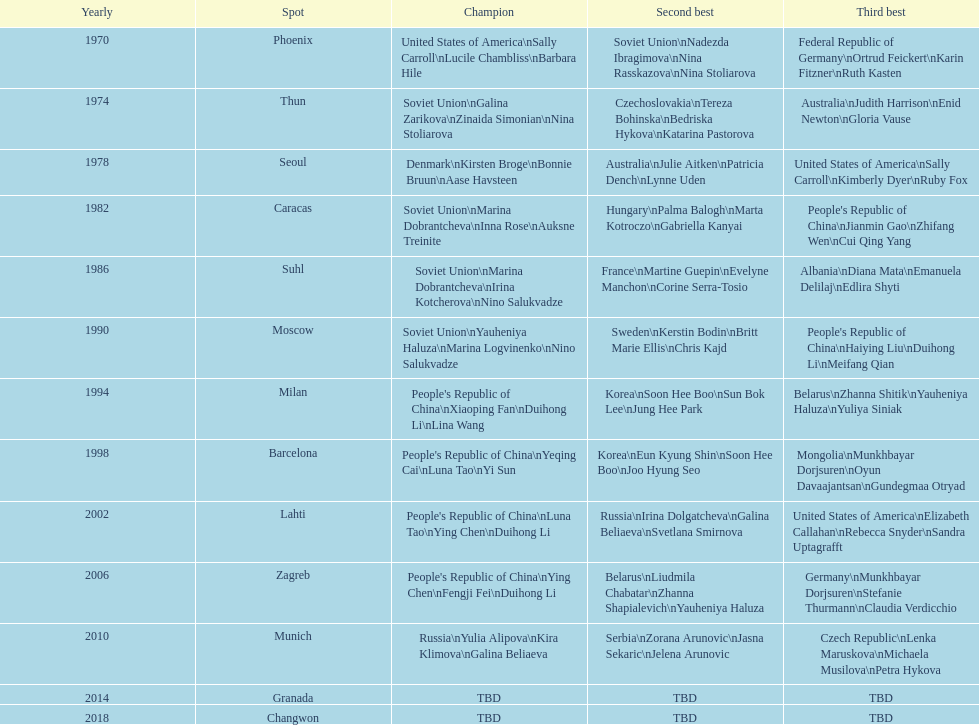What is the first place listed in this chart? Phoenix. 